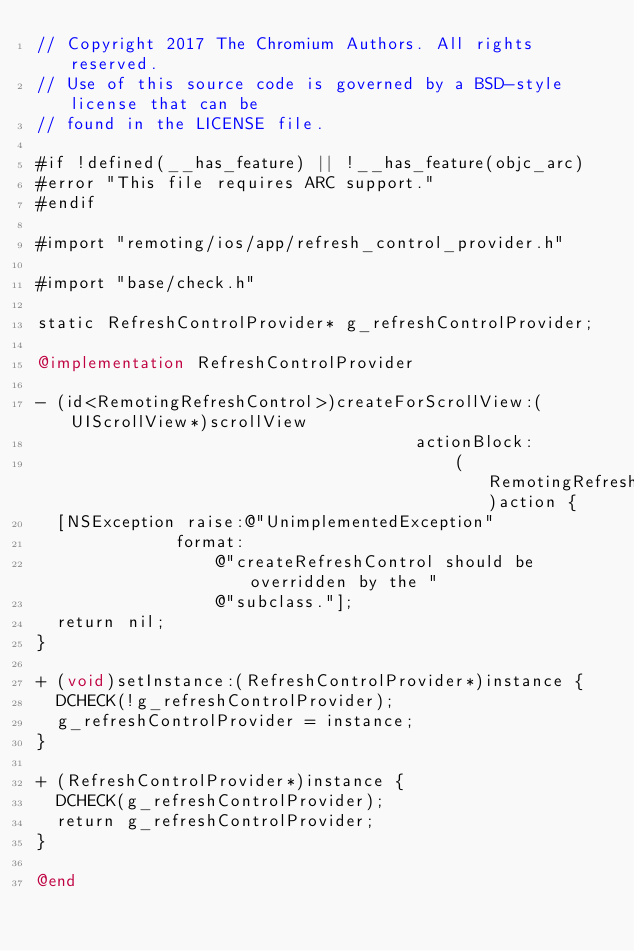<code> <loc_0><loc_0><loc_500><loc_500><_ObjectiveC_>// Copyright 2017 The Chromium Authors. All rights reserved.
// Use of this source code is governed by a BSD-style license that can be
// found in the LICENSE file.

#if !defined(__has_feature) || !__has_feature(objc_arc)
#error "This file requires ARC support."
#endif

#import "remoting/ios/app/refresh_control_provider.h"

#import "base/check.h"

static RefreshControlProvider* g_refreshControlProvider;

@implementation RefreshControlProvider

- (id<RemotingRefreshControl>)createForScrollView:(UIScrollView*)scrollView
                                      actionBlock:
                                          (RemotingRefreshAction)action {
  [NSException raise:@"UnimplementedException"
              format:
                  @"createRefreshControl should be overridden by the "
                  @"subclass."];
  return nil;
}

+ (void)setInstance:(RefreshControlProvider*)instance {
  DCHECK(!g_refreshControlProvider);
  g_refreshControlProvider = instance;
}

+ (RefreshControlProvider*)instance {
  DCHECK(g_refreshControlProvider);
  return g_refreshControlProvider;
}

@end
</code> 